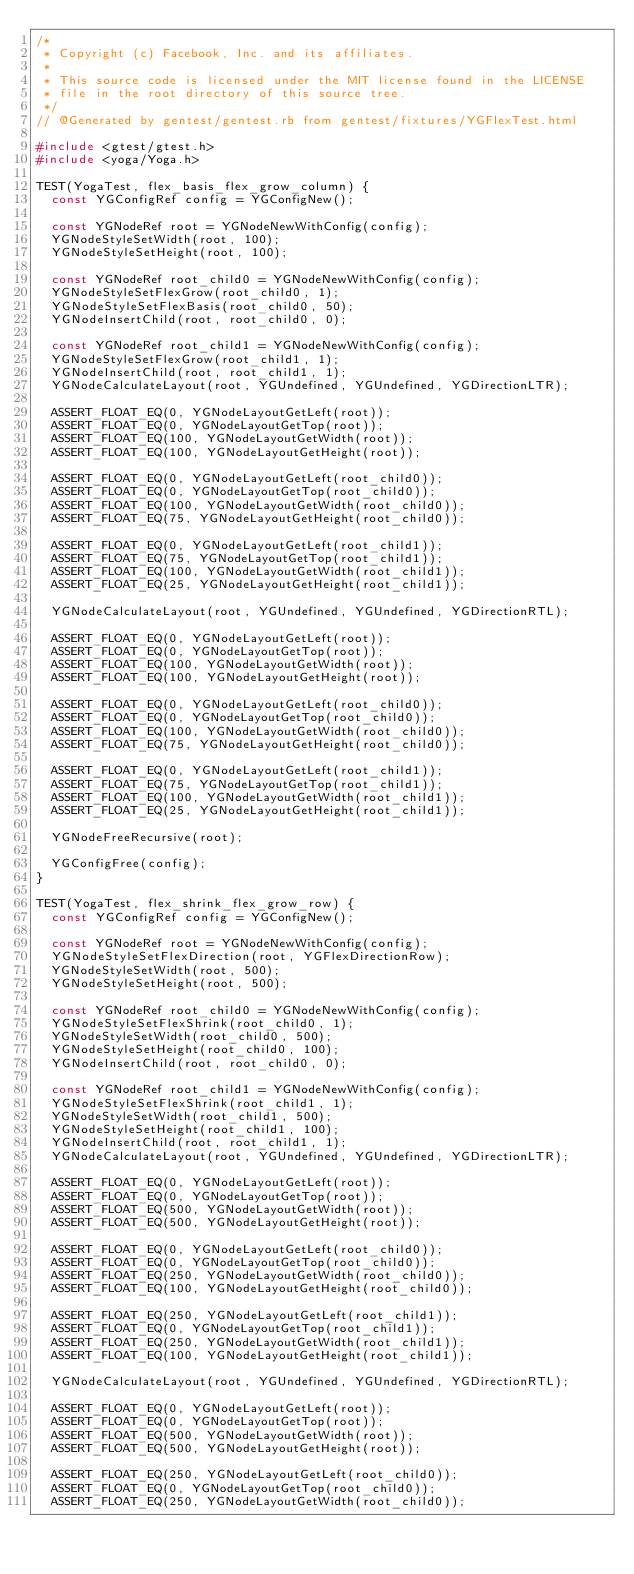Convert code to text. <code><loc_0><loc_0><loc_500><loc_500><_C++_>/*
 * Copyright (c) Facebook, Inc. and its affiliates.
 *
 * This source code is licensed under the MIT license found in the LICENSE
 * file in the root directory of this source tree.
 */
// @Generated by gentest/gentest.rb from gentest/fixtures/YGFlexTest.html

#include <gtest/gtest.h>
#include <yoga/Yoga.h>

TEST(YogaTest, flex_basis_flex_grow_column) {
  const YGConfigRef config = YGConfigNew();

  const YGNodeRef root = YGNodeNewWithConfig(config);
  YGNodeStyleSetWidth(root, 100);
  YGNodeStyleSetHeight(root, 100);

  const YGNodeRef root_child0 = YGNodeNewWithConfig(config);
  YGNodeStyleSetFlexGrow(root_child0, 1);
  YGNodeStyleSetFlexBasis(root_child0, 50);
  YGNodeInsertChild(root, root_child0, 0);

  const YGNodeRef root_child1 = YGNodeNewWithConfig(config);
  YGNodeStyleSetFlexGrow(root_child1, 1);
  YGNodeInsertChild(root, root_child1, 1);
  YGNodeCalculateLayout(root, YGUndefined, YGUndefined, YGDirectionLTR);

  ASSERT_FLOAT_EQ(0, YGNodeLayoutGetLeft(root));
  ASSERT_FLOAT_EQ(0, YGNodeLayoutGetTop(root));
  ASSERT_FLOAT_EQ(100, YGNodeLayoutGetWidth(root));
  ASSERT_FLOAT_EQ(100, YGNodeLayoutGetHeight(root));

  ASSERT_FLOAT_EQ(0, YGNodeLayoutGetLeft(root_child0));
  ASSERT_FLOAT_EQ(0, YGNodeLayoutGetTop(root_child0));
  ASSERT_FLOAT_EQ(100, YGNodeLayoutGetWidth(root_child0));
  ASSERT_FLOAT_EQ(75, YGNodeLayoutGetHeight(root_child0));

  ASSERT_FLOAT_EQ(0, YGNodeLayoutGetLeft(root_child1));
  ASSERT_FLOAT_EQ(75, YGNodeLayoutGetTop(root_child1));
  ASSERT_FLOAT_EQ(100, YGNodeLayoutGetWidth(root_child1));
  ASSERT_FLOAT_EQ(25, YGNodeLayoutGetHeight(root_child1));

  YGNodeCalculateLayout(root, YGUndefined, YGUndefined, YGDirectionRTL);

  ASSERT_FLOAT_EQ(0, YGNodeLayoutGetLeft(root));
  ASSERT_FLOAT_EQ(0, YGNodeLayoutGetTop(root));
  ASSERT_FLOAT_EQ(100, YGNodeLayoutGetWidth(root));
  ASSERT_FLOAT_EQ(100, YGNodeLayoutGetHeight(root));

  ASSERT_FLOAT_EQ(0, YGNodeLayoutGetLeft(root_child0));
  ASSERT_FLOAT_EQ(0, YGNodeLayoutGetTop(root_child0));
  ASSERT_FLOAT_EQ(100, YGNodeLayoutGetWidth(root_child0));
  ASSERT_FLOAT_EQ(75, YGNodeLayoutGetHeight(root_child0));

  ASSERT_FLOAT_EQ(0, YGNodeLayoutGetLeft(root_child1));
  ASSERT_FLOAT_EQ(75, YGNodeLayoutGetTop(root_child1));
  ASSERT_FLOAT_EQ(100, YGNodeLayoutGetWidth(root_child1));
  ASSERT_FLOAT_EQ(25, YGNodeLayoutGetHeight(root_child1));

  YGNodeFreeRecursive(root);

  YGConfigFree(config);
}

TEST(YogaTest, flex_shrink_flex_grow_row) {
  const YGConfigRef config = YGConfigNew();

  const YGNodeRef root = YGNodeNewWithConfig(config);
  YGNodeStyleSetFlexDirection(root, YGFlexDirectionRow);
  YGNodeStyleSetWidth(root, 500);
  YGNodeStyleSetHeight(root, 500);

  const YGNodeRef root_child0 = YGNodeNewWithConfig(config);
  YGNodeStyleSetFlexShrink(root_child0, 1);
  YGNodeStyleSetWidth(root_child0, 500);
  YGNodeStyleSetHeight(root_child0, 100);
  YGNodeInsertChild(root, root_child0, 0);

  const YGNodeRef root_child1 = YGNodeNewWithConfig(config);
  YGNodeStyleSetFlexShrink(root_child1, 1);
  YGNodeStyleSetWidth(root_child1, 500);
  YGNodeStyleSetHeight(root_child1, 100);
  YGNodeInsertChild(root, root_child1, 1);
  YGNodeCalculateLayout(root, YGUndefined, YGUndefined, YGDirectionLTR);

  ASSERT_FLOAT_EQ(0, YGNodeLayoutGetLeft(root));
  ASSERT_FLOAT_EQ(0, YGNodeLayoutGetTop(root));
  ASSERT_FLOAT_EQ(500, YGNodeLayoutGetWidth(root));
  ASSERT_FLOAT_EQ(500, YGNodeLayoutGetHeight(root));

  ASSERT_FLOAT_EQ(0, YGNodeLayoutGetLeft(root_child0));
  ASSERT_FLOAT_EQ(0, YGNodeLayoutGetTop(root_child0));
  ASSERT_FLOAT_EQ(250, YGNodeLayoutGetWidth(root_child0));
  ASSERT_FLOAT_EQ(100, YGNodeLayoutGetHeight(root_child0));

  ASSERT_FLOAT_EQ(250, YGNodeLayoutGetLeft(root_child1));
  ASSERT_FLOAT_EQ(0, YGNodeLayoutGetTop(root_child1));
  ASSERT_FLOAT_EQ(250, YGNodeLayoutGetWidth(root_child1));
  ASSERT_FLOAT_EQ(100, YGNodeLayoutGetHeight(root_child1));

  YGNodeCalculateLayout(root, YGUndefined, YGUndefined, YGDirectionRTL);

  ASSERT_FLOAT_EQ(0, YGNodeLayoutGetLeft(root));
  ASSERT_FLOAT_EQ(0, YGNodeLayoutGetTop(root));
  ASSERT_FLOAT_EQ(500, YGNodeLayoutGetWidth(root));
  ASSERT_FLOAT_EQ(500, YGNodeLayoutGetHeight(root));

  ASSERT_FLOAT_EQ(250, YGNodeLayoutGetLeft(root_child0));
  ASSERT_FLOAT_EQ(0, YGNodeLayoutGetTop(root_child0));
  ASSERT_FLOAT_EQ(250, YGNodeLayoutGetWidth(root_child0));</code> 